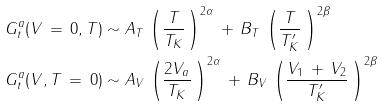Convert formula to latex. <formula><loc_0><loc_0><loc_500><loc_500>G _ { t } ^ { a } ( V \, = \, 0 , T ) & \sim A _ { T } \, \left ( \frac { T } { T _ { K } } \, \right ) ^ { 2 \alpha } \, + \, B _ { T } \, \left ( \frac { T } { T ^ { \prime } _ { K } } \, \right ) ^ { 2 \beta } \\ G _ { t } ^ { a } ( V , T \, = \, 0 ) & \sim A _ { V } \, \left ( \frac { 2 V _ { a } } { T _ { K } } \, \right ) ^ { 2 \alpha } \, + \, B _ { V } \, \left ( \frac { V _ { 1 } \, + \, V _ { 2 } } { T ^ { \prime } _ { K } } \, \right ) ^ { 2 \beta }</formula> 